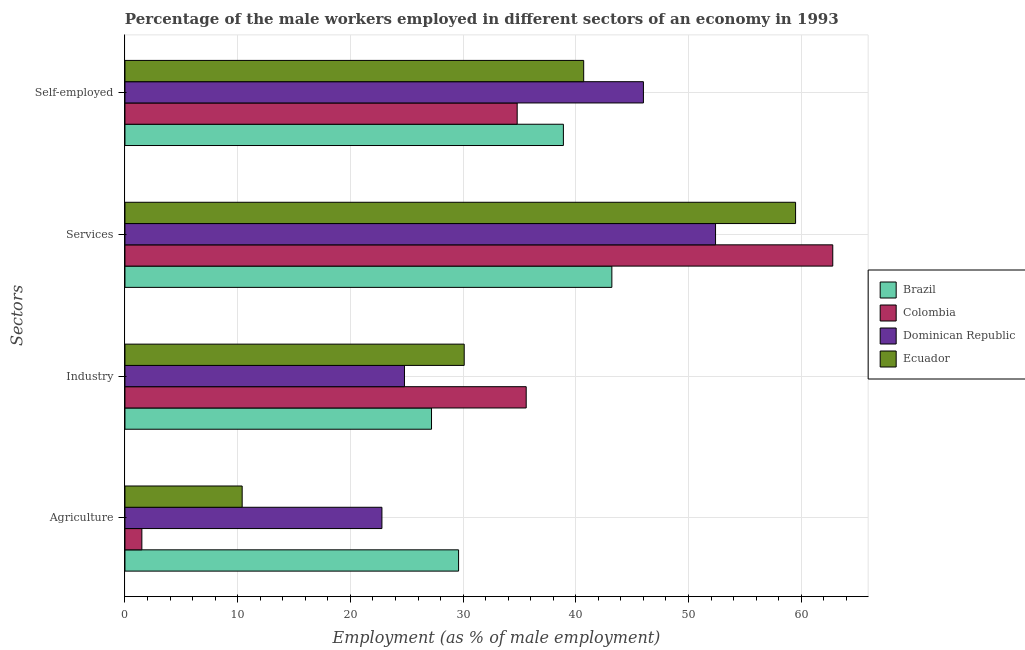How many different coloured bars are there?
Keep it short and to the point. 4. How many groups of bars are there?
Make the answer very short. 4. How many bars are there on the 4th tick from the bottom?
Ensure brevity in your answer.  4. What is the label of the 1st group of bars from the top?
Give a very brief answer. Self-employed. What is the percentage of male workers in services in Brazil?
Offer a very short reply. 43.2. Across all countries, what is the maximum percentage of male workers in agriculture?
Ensure brevity in your answer.  29.6. In which country was the percentage of self employed male workers maximum?
Offer a very short reply. Dominican Republic. In which country was the percentage of male workers in agriculture minimum?
Provide a succinct answer. Colombia. What is the total percentage of male workers in industry in the graph?
Make the answer very short. 117.7. What is the difference between the percentage of male workers in agriculture in Ecuador and that in Colombia?
Provide a short and direct response. 8.9. What is the difference between the percentage of male workers in industry in Brazil and the percentage of male workers in agriculture in Dominican Republic?
Keep it short and to the point. 4.4. What is the average percentage of self employed male workers per country?
Ensure brevity in your answer.  40.1. What is the difference between the percentage of male workers in services and percentage of male workers in agriculture in Ecuador?
Make the answer very short. 49.1. What is the ratio of the percentage of self employed male workers in Dominican Republic to that in Brazil?
Offer a very short reply. 1.18. Is the difference between the percentage of male workers in agriculture in Colombia and Ecuador greater than the difference between the percentage of male workers in services in Colombia and Ecuador?
Offer a terse response. No. What is the difference between the highest and the second highest percentage of male workers in industry?
Ensure brevity in your answer.  5.5. What is the difference between the highest and the lowest percentage of self employed male workers?
Your answer should be compact. 11.2. In how many countries, is the percentage of male workers in industry greater than the average percentage of male workers in industry taken over all countries?
Offer a very short reply. 2. What does the 2nd bar from the top in Agriculture represents?
Provide a short and direct response. Dominican Republic. What does the 3rd bar from the bottom in Services represents?
Your answer should be compact. Dominican Republic. Is it the case that in every country, the sum of the percentage of male workers in agriculture and percentage of male workers in industry is greater than the percentage of male workers in services?
Provide a succinct answer. No. Are all the bars in the graph horizontal?
Make the answer very short. Yes. How many countries are there in the graph?
Provide a succinct answer. 4. Does the graph contain grids?
Your answer should be very brief. Yes. Where does the legend appear in the graph?
Keep it short and to the point. Center right. How many legend labels are there?
Provide a short and direct response. 4. How are the legend labels stacked?
Make the answer very short. Vertical. What is the title of the graph?
Give a very brief answer. Percentage of the male workers employed in different sectors of an economy in 1993. What is the label or title of the X-axis?
Provide a succinct answer. Employment (as % of male employment). What is the label or title of the Y-axis?
Ensure brevity in your answer.  Sectors. What is the Employment (as % of male employment) of Brazil in Agriculture?
Offer a very short reply. 29.6. What is the Employment (as % of male employment) in Colombia in Agriculture?
Provide a succinct answer. 1.5. What is the Employment (as % of male employment) of Dominican Republic in Agriculture?
Give a very brief answer. 22.8. What is the Employment (as % of male employment) of Ecuador in Agriculture?
Offer a very short reply. 10.4. What is the Employment (as % of male employment) of Brazil in Industry?
Make the answer very short. 27.2. What is the Employment (as % of male employment) in Colombia in Industry?
Offer a terse response. 35.6. What is the Employment (as % of male employment) of Dominican Republic in Industry?
Ensure brevity in your answer.  24.8. What is the Employment (as % of male employment) in Ecuador in Industry?
Your answer should be very brief. 30.1. What is the Employment (as % of male employment) in Brazil in Services?
Your answer should be compact. 43.2. What is the Employment (as % of male employment) in Colombia in Services?
Your response must be concise. 62.8. What is the Employment (as % of male employment) in Dominican Republic in Services?
Your response must be concise. 52.4. What is the Employment (as % of male employment) of Ecuador in Services?
Offer a very short reply. 59.5. What is the Employment (as % of male employment) in Brazil in Self-employed?
Provide a succinct answer. 38.9. What is the Employment (as % of male employment) of Colombia in Self-employed?
Give a very brief answer. 34.8. What is the Employment (as % of male employment) of Dominican Republic in Self-employed?
Provide a short and direct response. 46. What is the Employment (as % of male employment) of Ecuador in Self-employed?
Offer a terse response. 40.7. Across all Sectors, what is the maximum Employment (as % of male employment) in Brazil?
Your answer should be compact. 43.2. Across all Sectors, what is the maximum Employment (as % of male employment) in Colombia?
Provide a succinct answer. 62.8. Across all Sectors, what is the maximum Employment (as % of male employment) of Dominican Republic?
Your response must be concise. 52.4. Across all Sectors, what is the maximum Employment (as % of male employment) in Ecuador?
Provide a short and direct response. 59.5. Across all Sectors, what is the minimum Employment (as % of male employment) of Brazil?
Your response must be concise. 27.2. Across all Sectors, what is the minimum Employment (as % of male employment) in Dominican Republic?
Keep it short and to the point. 22.8. Across all Sectors, what is the minimum Employment (as % of male employment) of Ecuador?
Your answer should be very brief. 10.4. What is the total Employment (as % of male employment) in Brazil in the graph?
Ensure brevity in your answer.  138.9. What is the total Employment (as % of male employment) in Colombia in the graph?
Keep it short and to the point. 134.7. What is the total Employment (as % of male employment) of Dominican Republic in the graph?
Make the answer very short. 146. What is the total Employment (as % of male employment) in Ecuador in the graph?
Give a very brief answer. 140.7. What is the difference between the Employment (as % of male employment) in Colombia in Agriculture and that in Industry?
Give a very brief answer. -34.1. What is the difference between the Employment (as % of male employment) of Dominican Republic in Agriculture and that in Industry?
Give a very brief answer. -2. What is the difference between the Employment (as % of male employment) in Ecuador in Agriculture and that in Industry?
Your answer should be very brief. -19.7. What is the difference between the Employment (as % of male employment) of Brazil in Agriculture and that in Services?
Make the answer very short. -13.6. What is the difference between the Employment (as % of male employment) in Colombia in Agriculture and that in Services?
Provide a short and direct response. -61.3. What is the difference between the Employment (as % of male employment) of Dominican Republic in Agriculture and that in Services?
Give a very brief answer. -29.6. What is the difference between the Employment (as % of male employment) of Ecuador in Agriculture and that in Services?
Ensure brevity in your answer.  -49.1. What is the difference between the Employment (as % of male employment) in Colombia in Agriculture and that in Self-employed?
Offer a terse response. -33.3. What is the difference between the Employment (as % of male employment) of Dominican Republic in Agriculture and that in Self-employed?
Ensure brevity in your answer.  -23.2. What is the difference between the Employment (as % of male employment) of Ecuador in Agriculture and that in Self-employed?
Offer a very short reply. -30.3. What is the difference between the Employment (as % of male employment) of Brazil in Industry and that in Services?
Provide a succinct answer. -16. What is the difference between the Employment (as % of male employment) of Colombia in Industry and that in Services?
Provide a succinct answer. -27.2. What is the difference between the Employment (as % of male employment) in Dominican Republic in Industry and that in Services?
Provide a short and direct response. -27.6. What is the difference between the Employment (as % of male employment) in Ecuador in Industry and that in Services?
Ensure brevity in your answer.  -29.4. What is the difference between the Employment (as % of male employment) in Brazil in Industry and that in Self-employed?
Provide a succinct answer. -11.7. What is the difference between the Employment (as % of male employment) in Colombia in Industry and that in Self-employed?
Your answer should be very brief. 0.8. What is the difference between the Employment (as % of male employment) in Dominican Republic in Industry and that in Self-employed?
Your answer should be very brief. -21.2. What is the difference between the Employment (as % of male employment) of Brazil in Services and that in Self-employed?
Ensure brevity in your answer.  4.3. What is the difference between the Employment (as % of male employment) of Ecuador in Services and that in Self-employed?
Your response must be concise. 18.8. What is the difference between the Employment (as % of male employment) of Brazil in Agriculture and the Employment (as % of male employment) of Dominican Republic in Industry?
Keep it short and to the point. 4.8. What is the difference between the Employment (as % of male employment) of Colombia in Agriculture and the Employment (as % of male employment) of Dominican Republic in Industry?
Offer a very short reply. -23.3. What is the difference between the Employment (as % of male employment) of Colombia in Agriculture and the Employment (as % of male employment) of Ecuador in Industry?
Ensure brevity in your answer.  -28.6. What is the difference between the Employment (as % of male employment) of Dominican Republic in Agriculture and the Employment (as % of male employment) of Ecuador in Industry?
Make the answer very short. -7.3. What is the difference between the Employment (as % of male employment) of Brazil in Agriculture and the Employment (as % of male employment) of Colombia in Services?
Ensure brevity in your answer.  -33.2. What is the difference between the Employment (as % of male employment) of Brazil in Agriculture and the Employment (as % of male employment) of Dominican Republic in Services?
Your answer should be very brief. -22.8. What is the difference between the Employment (as % of male employment) of Brazil in Agriculture and the Employment (as % of male employment) of Ecuador in Services?
Make the answer very short. -29.9. What is the difference between the Employment (as % of male employment) in Colombia in Agriculture and the Employment (as % of male employment) in Dominican Republic in Services?
Make the answer very short. -50.9. What is the difference between the Employment (as % of male employment) in Colombia in Agriculture and the Employment (as % of male employment) in Ecuador in Services?
Make the answer very short. -58. What is the difference between the Employment (as % of male employment) of Dominican Republic in Agriculture and the Employment (as % of male employment) of Ecuador in Services?
Your response must be concise. -36.7. What is the difference between the Employment (as % of male employment) in Brazil in Agriculture and the Employment (as % of male employment) in Dominican Republic in Self-employed?
Ensure brevity in your answer.  -16.4. What is the difference between the Employment (as % of male employment) of Brazil in Agriculture and the Employment (as % of male employment) of Ecuador in Self-employed?
Your answer should be very brief. -11.1. What is the difference between the Employment (as % of male employment) in Colombia in Agriculture and the Employment (as % of male employment) in Dominican Republic in Self-employed?
Your answer should be very brief. -44.5. What is the difference between the Employment (as % of male employment) in Colombia in Agriculture and the Employment (as % of male employment) in Ecuador in Self-employed?
Your answer should be very brief. -39.2. What is the difference between the Employment (as % of male employment) in Dominican Republic in Agriculture and the Employment (as % of male employment) in Ecuador in Self-employed?
Give a very brief answer. -17.9. What is the difference between the Employment (as % of male employment) of Brazil in Industry and the Employment (as % of male employment) of Colombia in Services?
Ensure brevity in your answer.  -35.6. What is the difference between the Employment (as % of male employment) of Brazil in Industry and the Employment (as % of male employment) of Dominican Republic in Services?
Make the answer very short. -25.2. What is the difference between the Employment (as % of male employment) of Brazil in Industry and the Employment (as % of male employment) of Ecuador in Services?
Make the answer very short. -32.3. What is the difference between the Employment (as % of male employment) in Colombia in Industry and the Employment (as % of male employment) in Dominican Republic in Services?
Give a very brief answer. -16.8. What is the difference between the Employment (as % of male employment) in Colombia in Industry and the Employment (as % of male employment) in Ecuador in Services?
Give a very brief answer. -23.9. What is the difference between the Employment (as % of male employment) in Dominican Republic in Industry and the Employment (as % of male employment) in Ecuador in Services?
Make the answer very short. -34.7. What is the difference between the Employment (as % of male employment) in Brazil in Industry and the Employment (as % of male employment) in Colombia in Self-employed?
Ensure brevity in your answer.  -7.6. What is the difference between the Employment (as % of male employment) of Brazil in Industry and the Employment (as % of male employment) of Dominican Republic in Self-employed?
Provide a short and direct response. -18.8. What is the difference between the Employment (as % of male employment) of Brazil in Industry and the Employment (as % of male employment) of Ecuador in Self-employed?
Keep it short and to the point. -13.5. What is the difference between the Employment (as % of male employment) of Colombia in Industry and the Employment (as % of male employment) of Dominican Republic in Self-employed?
Provide a short and direct response. -10.4. What is the difference between the Employment (as % of male employment) in Dominican Republic in Industry and the Employment (as % of male employment) in Ecuador in Self-employed?
Give a very brief answer. -15.9. What is the difference between the Employment (as % of male employment) in Brazil in Services and the Employment (as % of male employment) in Colombia in Self-employed?
Provide a succinct answer. 8.4. What is the difference between the Employment (as % of male employment) in Brazil in Services and the Employment (as % of male employment) in Dominican Republic in Self-employed?
Offer a terse response. -2.8. What is the difference between the Employment (as % of male employment) of Brazil in Services and the Employment (as % of male employment) of Ecuador in Self-employed?
Ensure brevity in your answer.  2.5. What is the difference between the Employment (as % of male employment) in Colombia in Services and the Employment (as % of male employment) in Ecuador in Self-employed?
Provide a succinct answer. 22.1. What is the average Employment (as % of male employment) of Brazil per Sectors?
Offer a terse response. 34.73. What is the average Employment (as % of male employment) in Colombia per Sectors?
Make the answer very short. 33.67. What is the average Employment (as % of male employment) of Dominican Republic per Sectors?
Provide a succinct answer. 36.5. What is the average Employment (as % of male employment) of Ecuador per Sectors?
Offer a very short reply. 35.17. What is the difference between the Employment (as % of male employment) of Brazil and Employment (as % of male employment) of Colombia in Agriculture?
Your response must be concise. 28.1. What is the difference between the Employment (as % of male employment) of Brazil and Employment (as % of male employment) of Dominican Republic in Agriculture?
Your response must be concise. 6.8. What is the difference between the Employment (as % of male employment) in Colombia and Employment (as % of male employment) in Dominican Republic in Agriculture?
Keep it short and to the point. -21.3. What is the difference between the Employment (as % of male employment) of Brazil and Employment (as % of male employment) of Colombia in Industry?
Offer a very short reply. -8.4. What is the difference between the Employment (as % of male employment) of Brazil and Employment (as % of male employment) of Dominican Republic in Industry?
Offer a very short reply. 2.4. What is the difference between the Employment (as % of male employment) of Brazil and Employment (as % of male employment) of Ecuador in Industry?
Offer a terse response. -2.9. What is the difference between the Employment (as % of male employment) in Colombia and Employment (as % of male employment) in Dominican Republic in Industry?
Offer a very short reply. 10.8. What is the difference between the Employment (as % of male employment) of Brazil and Employment (as % of male employment) of Colombia in Services?
Offer a very short reply. -19.6. What is the difference between the Employment (as % of male employment) of Brazil and Employment (as % of male employment) of Ecuador in Services?
Your response must be concise. -16.3. What is the difference between the Employment (as % of male employment) in Colombia and Employment (as % of male employment) in Dominican Republic in Services?
Make the answer very short. 10.4. What is the difference between the Employment (as % of male employment) in Brazil and Employment (as % of male employment) in Ecuador in Self-employed?
Make the answer very short. -1.8. What is the difference between the Employment (as % of male employment) of Colombia and Employment (as % of male employment) of Ecuador in Self-employed?
Offer a very short reply. -5.9. What is the ratio of the Employment (as % of male employment) of Brazil in Agriculture to that in Industry?
Give a very brief answer. 1.09. What is the ratio of the Employment (as % of male employment) of Colombia in Agriculture to that in Industry?
Provide a succinct answer. 0.04. What is the ratio of the Employment (as % of male employment) of Dominican Republic in Agriculture to that in Industry?
Your response must be concise. 0.92. What is the ratio of the Employment (as % of male employment) of Ecuador in Agriculture to that in Industry?
Your answer should be compact. 0.35. What is the ratio of the Employment (as % of male employment) of Brazil in Agriculture to that in Services?
Make the answer very short. 0.69. What is the ratio of the Employment (as % of male employment) of Colombia in Agriculture to that in Services?
Offer a terse response. 0.02. What is the ratio of the Employment (as % of male employment) of Dominican Republic in Agriculture to that in Services?
Ensure brevity in your answer.  0.44. What is the ratio of the Employment (as % of male employment) in Ecuador in Agriculture to that in Services?
Offer a terse response. 0.17. What is the ratio of the Employment (as % of male employment) of Brazil in Agriculture to that in Self-employed?
Provide a short and direct response. 0.76. What is the ratio of the Employment (as % of male employment) in Colombia in Agriculture to that in Self-employed?
Offer a very short reply. 0.04. What is the ratio of the Employment (as % of male employment) of Dominican Republic in Agriculture to that in Self-employed?
Provide a succinct answer. 0.5. What is the ratio of the Employment (as % of male employment) in Ecuador in Agriculture to that in Self-employed?
Offer a terse response. 0.26. What is the ratio of the Employment (as % of male employment) of Brazil in Industry to that in Services?
Your answer should be very brief. 0.63. What is the ratio of the Employment (as % of male employment) in Colombia in Industry to that in Services?
Make the answer very short. 0.57. What is the ratio of the Employment (as % of male employment) of Dominican Republic in Industry to that in Services?
Give a very brief answer. 0.47. What is the ratio of the Employment (as % of male employment) of Ecuador in Industry to that in Services?
Give a very brief answer. 0.51. What is the ratio of the Employment (as % of male employment) in Brazil in Industry to that in Self-employed?
Provide a succinct answer. 0.7. What is the ratio of the Employment (as % of male employment) in Colombia in Industry to that in Self-employed?
Give a very brief answer. 1.02. What is the ratio of the Employment (as % of male employment) of Dominican Republic in Industry to that in Self-employed?
Your answer should be very brief. 0.54. What is the ratio of the Employment (as % of male employment) of Ecuador in Industry to that in Self-employed?
Your response must be concise. 0.74. What is the ratio of the Employment (as % of male employment) of Brazil in Services to that in Self-employed?
Provide a succinct answer. 1.11. What is the ratio of the Employment (as % of male employment) in Colombia in Services to that in Self-employed?
Ensure brevity in your answer.  1.8. What is the ratio of the Employment (as % of male employment) of Dominican Republic in Services to that in Self-employed?
Provide a succinct answer. 1.14. What is the ratio of the Employment (as % of male employment) of Ecuador in Services to that in Self-employed?
Keep it short and to the point. 1.46. What is the difference between the highest and the second highest Employment (as % of male employment) in Colombia?
Provide a succinct answer. 27.2. What is the difference between the highest and the second highest Employment (as % of male employment) of Dominican Republic?
Your answer should be very brief. 6.4. What is the difference between the highest and the lowest Employment (as % of male employment) in Colombia?
Offer a very short reply. 61.3. What is the difference between the highest and the lowest Employment (as % of male employment) in Dominican Republic?
Your answer should be very brief. 29.6. What is the difference between the highest and the lowest Employment (as % of male employment) in Ecuador?
Provide a short and direct response. 49.1. 